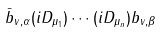<formula> <loc_0><loc_0><loc_500><loc_500>\bar { b } _ { v , \alpha } ( i D _ { \mu _ { 1 } } ) \cdots ( i D _ { \mu _ { n } } ) b _ { v , \beta }</formula> 